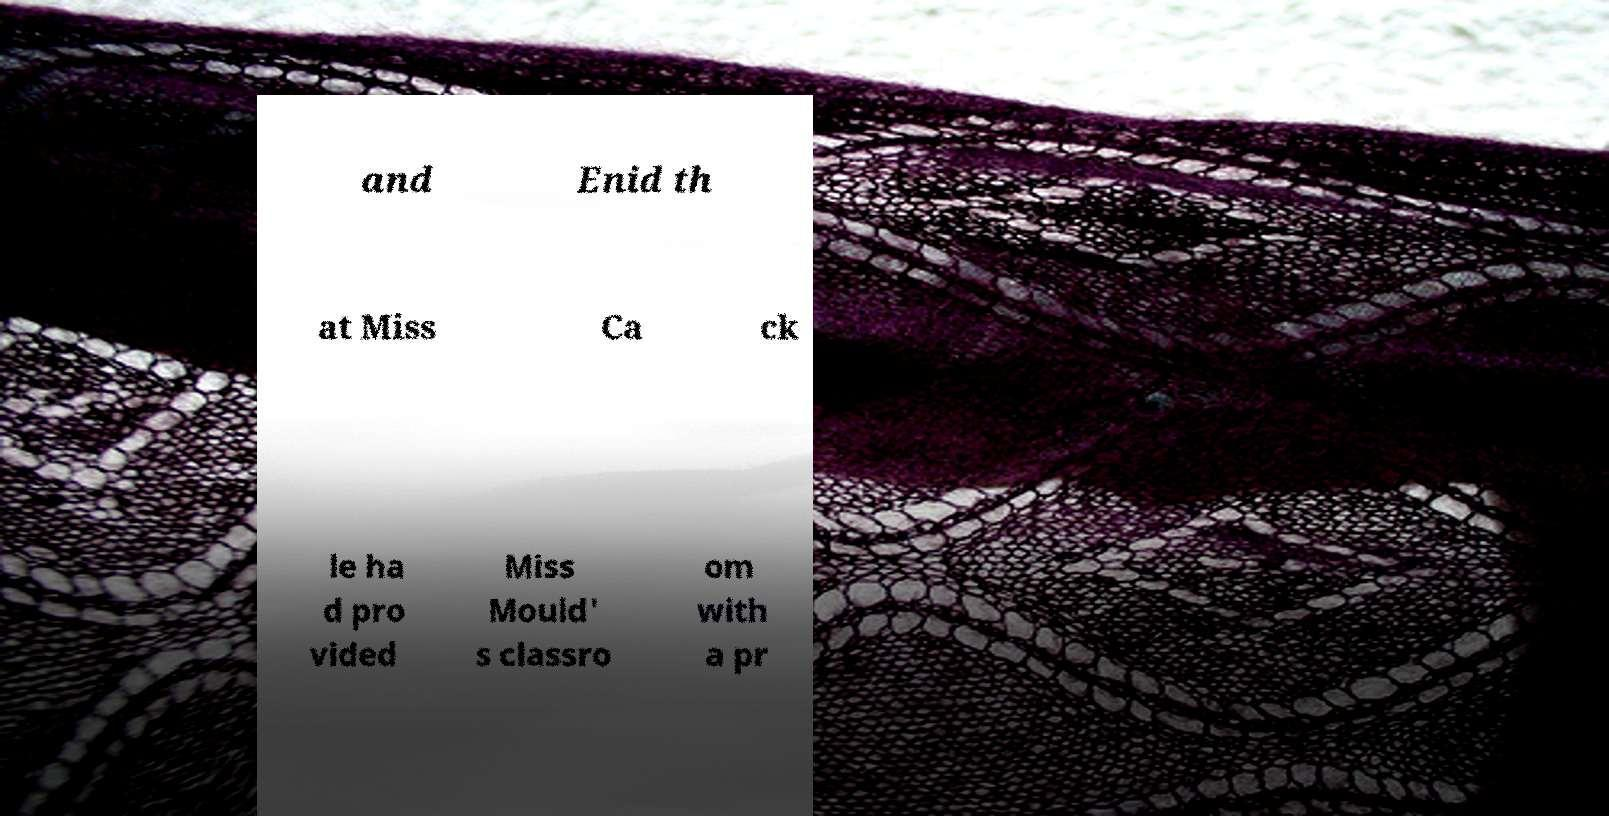Could you assist in decoding the text presented in this image and type it out clearly? and Enid th at Miss Ca ck le ha d pro vided Miss Mould' s classro om with a pr 